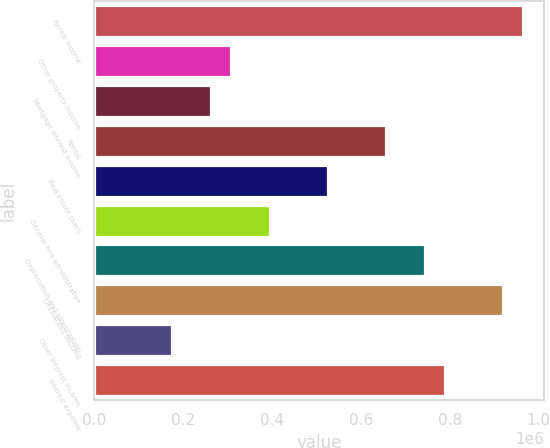Convert chart. <chart><loc_0><loc_0><loc_500><loc_500><bar_chart><fcel>Rental income<fcel>Other property income<fcel>Mortgage interest income<fcel>Rental<fcel>Real estate taxes<fcel>General and administrative<fcel>Depreciation and amortization<fcel>OPERATING INCOME<fcel>Other interest income<fcel>Interest expense<nl><fcel>964042<fcel>306741<fcel>262921<fcel>657301<fcel>525841<fcel>394381<fcel>744941<fcel>920222<fcel>175281<fcel>788761<nl></chart> 